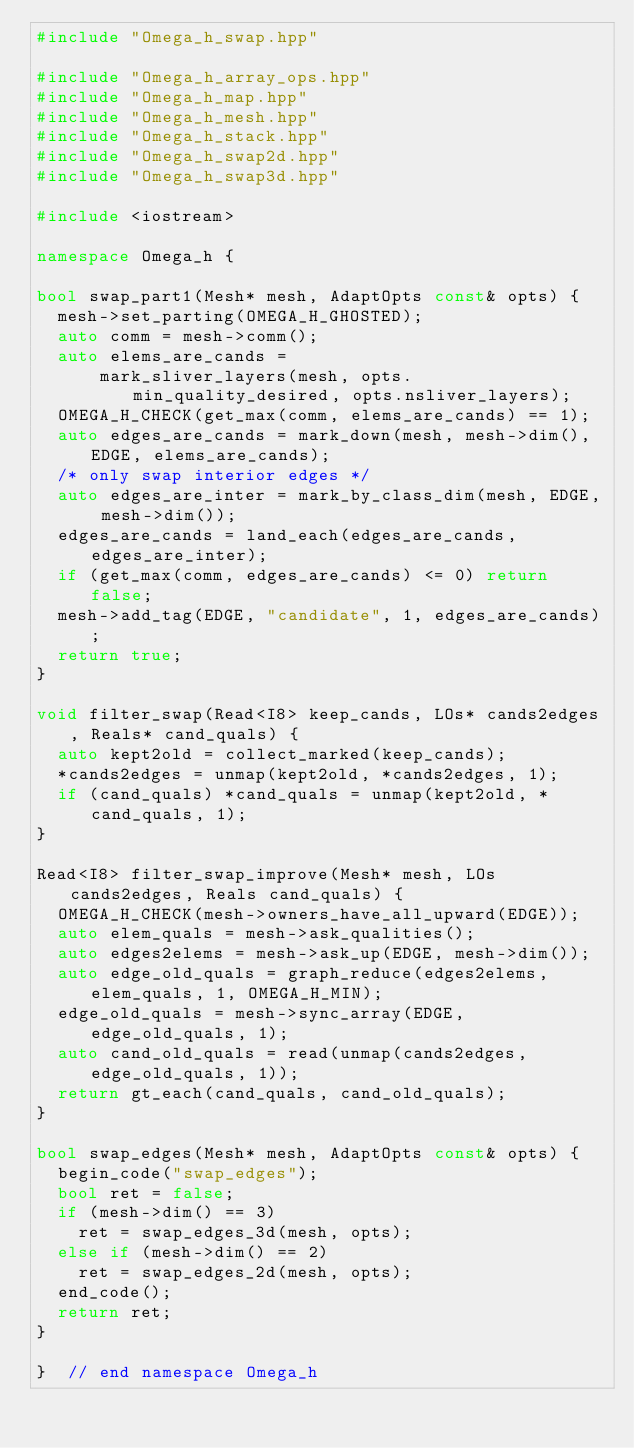<code> <loc_0><loc_0><loc_500><loc_500><_C++_>#include "Omega_h_swap.hpp"

#include "Omega_h_array_ops.hpp"
#include "Omega_h_map.hpp"
#include "Omega_h_mesh.hpp"
#include "Omega_h_stack.hpp"
#include "Omega_h_swap2d.hpp"
#include "Omega_h_swap3d.hpp"

#include <iostream>

namespace Omega_h {

bool swap_part1(Mesh* mesh, AdaptOpts const& opts) {
  mesh->set_parting(OMEGA_H_GHOSTED);
  auto comm = mesh->comm();
  auto elems_are_cands =
      mark_sliver_layers(mesh, opts.min_quality_desired, opts.nsliver_layers);
  OMEGA_H_CHECK(get_max(comm, elems_are_cands) == 1);
  auto edges_are_cands = mark_down(mesh, mesh->dim(), EDGE, elems_are_cands);
  /* only swap interior edges */
  auto edges_are_inter = mark_by_class_dim(mesh, EDGE, mesh->dim());
  edges_are_cands = land_each(edges_are_cands, edges_are_inter);
  if (get_max(comm, edges_are_cands) <= 0) return false;
  mesh->add_tag(EDGE, "candidate", 1, edges_are_cands);
  return true;
}

void filter_swap(Read<I8> keep_cands, LOs* cands2edges, Reals* cand_quals) {
  auto kept2old = collect_marked(keep_cands);
  *cands2edges = unmap(kept2old, *cands2edges, 1);
  if (cand_quals) *cand_quals = unmap(kept2old, *cand_quals, 1);
}

Read<I8> filter_swap_improve(Mesh* mesh, LOs cands2edges, Reals cand_quals) {
  OMEGA_H_CHECK(mesh->owners_have_all_upward(EDGE));
  auto elem_quals = mesh->ask_qualities();
  auto edges2elems = mesh->ask_up(EDGE, mesh->dim());
  auto edge_old_quals = graph_reduce(edges2elems, elem_quals, 1, OMEGA_H_MIN);
  edge_old_quals = mesh->sync_array(EDGE, edge_old_quals, 1);
  auto cand_old_quals = read(unmap(cands2edges, edge_old_quals, 1));
  return gt_each(cand_quals, cand_old_quals);
}

bool swap_edges(Mesh* mesh, AdaptOpts const& opts) {
  begin_code("swap_edges");
  bool ret = false;
  if (mesh->dim() == 3)
    ret = swap_edges_3d(mesh, opts);
  else if (mesh->dim() == 2)
    ret = swap_edges_2d(mesh, opts);
  end_code();
  return ret;
}

}  // end namespace Omega_h
</code> 